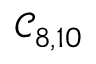<formula> <loc_0><loc_0><loc_500><loc_500>\mathcal { C } _ { 8 , 1 0 }</formula> 